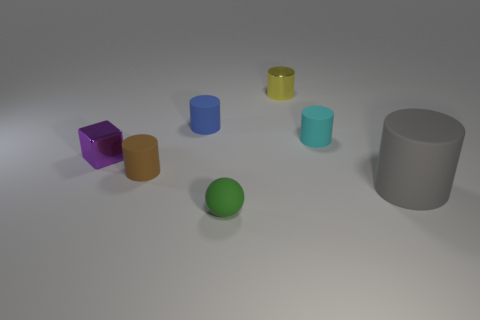Subtract all tiny blue matte cylinders. How many cylinders are left? 4 Add 1 tiny cyan rubber objects. How many objects exist? 8 Subtract all spheres. How many objects are left? 6 Subtract all blue cylinders. How many cylinders are left? 4 Subtract all green cylinders. Subtract all brown cubes. How many cylinders are left? 5 Subtract all green spheres. How many cyan cylinders are left? 1 Subtract all tiny yellow cylinders. Subtract all purple metal things. How many objects are left? 5 Add 6 large gray matte cylinders. How many large gray matte cylinders are left? 7 Add 2 brown objects. How many brown objects exist? 3 Subtract 0 blue blocks. How many objects are left? 7 